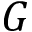Convert formula to latex. <formula><loc_0><loc_0><loc_500><loc_500>G</formula> 